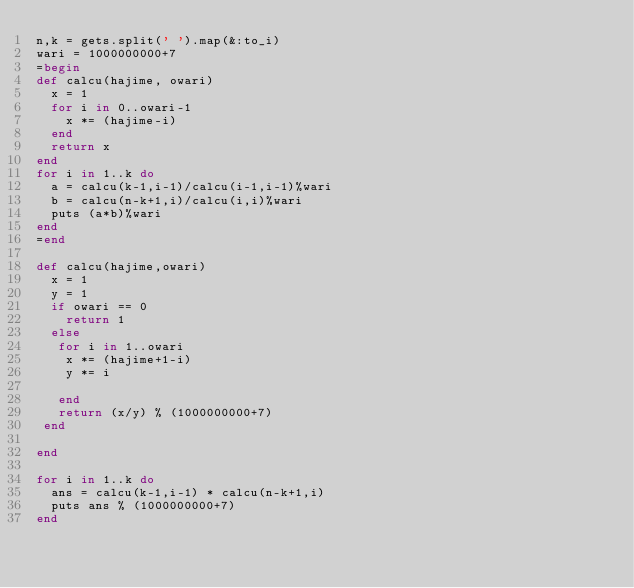<code> <loc_0><loc_0><loc_500><loc_500><_Ruby_>n,k = gets.split(' ').map(&:to_i)
wari = 1000000000+7
=begin
def calcu(hajime, owari)
  x = 1
  for i in 0..owari-1
    x *= (hajime-i)
  end
  return x
end
for i in 1..k do
  a = calcu(k-1,i-1)/calcu(i-1,i-1)%wari
  b = calcu(n-k+1,i)/calcu(i,i)%wari
  puts (a*b)%wari
end
=end

def calcu(hajime,owari)
  x = 1
  y = 1
  if owari == 0
    return 1
  else
   for i in 1..owari
    x *= (hajime+1-i)
    y *= i

   end
   return (x/y) % (1000000000+7)
 end

end

for i in 1..k do
  ans = calcu(k-1,i-1) * calcu(n-k+1,i)
  puts ans % (1000000000+7)
end
</code> 